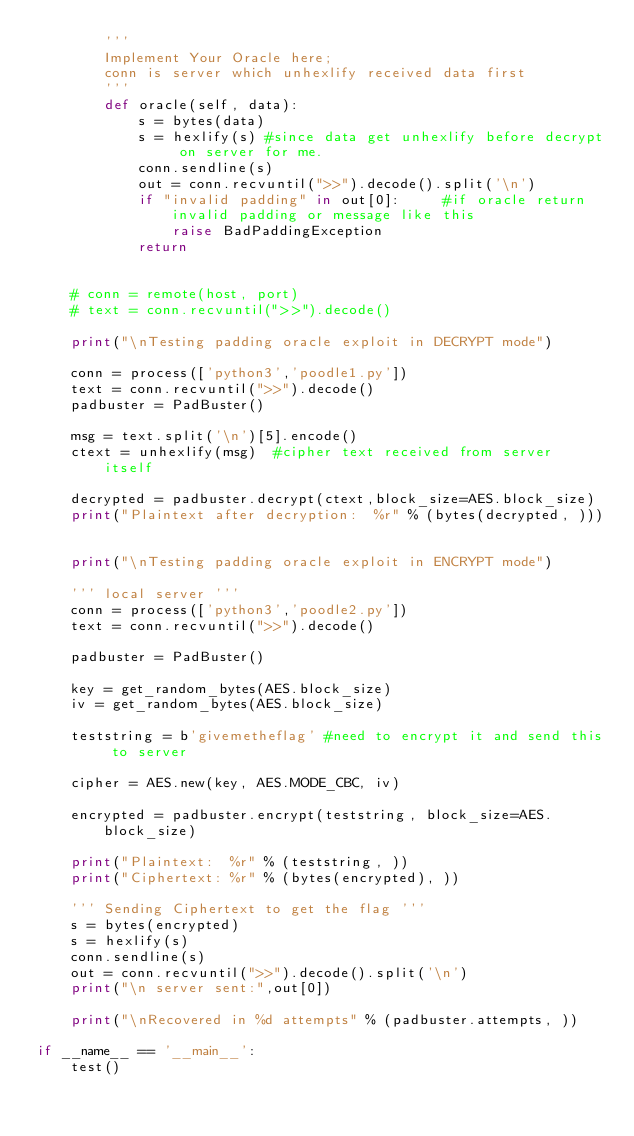Convert code to text. <code><loc_0><loc_0><loc_500><loc_500><_Python_>        '''
        Implement Your Oracle here;
        conn is server which unhexlify received data first
        '''
        def oracle(self, data):
            s = bytes(data)
            s = hexlify(s) #since data get unhexlify before decrypt on server for me.
            conn.sendline(s)
            out = conn.recvuntil(">>").decode().split('\n')
            if "invalid padding" in out[0]:     #if oracle return invalid padding or message like this
                raise BadPaddingException
            return


    # conn = remote(host, port)
    # text = conn.recvuntil(">>").decode()
    
    print("\nTesting padding oracle exploit in DECRYPT mode")

    conn = process(['python3','poodle1.py'])
    text = conn.recvuntil(">>").decode()        
    padbuster = PadBuster()

    msg = text.split('\n')[5].encode()
    ctext = unhexlify(msg)  #cipher text received from server itself

    decrypted = padbuster.decrypt(ctext,block_size=AES.block_size)
    print("Plaintext after decryption:  %r" % (bytes(decrypted, )))

    
    print("\nTesting padding oracle exploit in ENCRYPT mode")

    ''' local server '''
    conn = process(['python3','poodle2.py'])
    text = conn.recvuntil(">>").decode()        
    
    padbuster = PadBuster()

    key = get_random_bytes(AES.block_size)
    iv = get_random_bytes(AES.block_size)

    teststring = b'givemetheflag' #need to encrypt it and send this to server

    cipher = AES.new(key, AES.MODE_CBC, iv)

    encrypted = padbuster.encrypt(teststring, block_size=AES.block_size)

    print("Plaintext:  %r" % (teststring, ))
    print("Ciphertext: %r" % (bytes(encrypted), ))

    ''' Sending Ciphertext to get the flag '''
    s = bytes(encrypted)
    s = hexlify(s)
    conn.sendline(s)
    out = conn.recvuntil(">>").decode().split('\n')
    print("\n server sent:",out[0])

    print("\nRecovered in %d attempts" % (padbuster.attempts, ))

if __name__ == '__main__':
    test()
</code> 